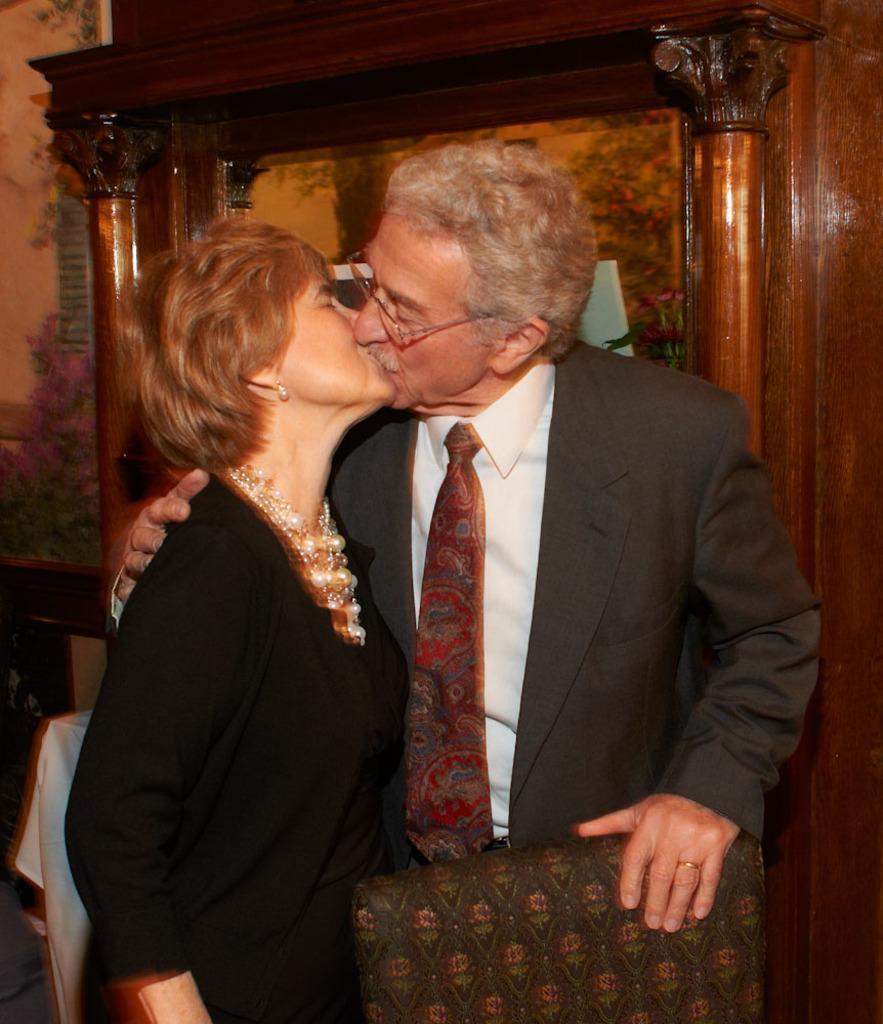Could you give a brief overview of what you see in this image? This picture is clicked inside. In the center there is a woman wearing black color dress and a man wearing a suit, both of them are standing and kissing each other. In the foreground there is a chair. In the background we can see a wall and a picture frame hanging on the wall and some other objects. 